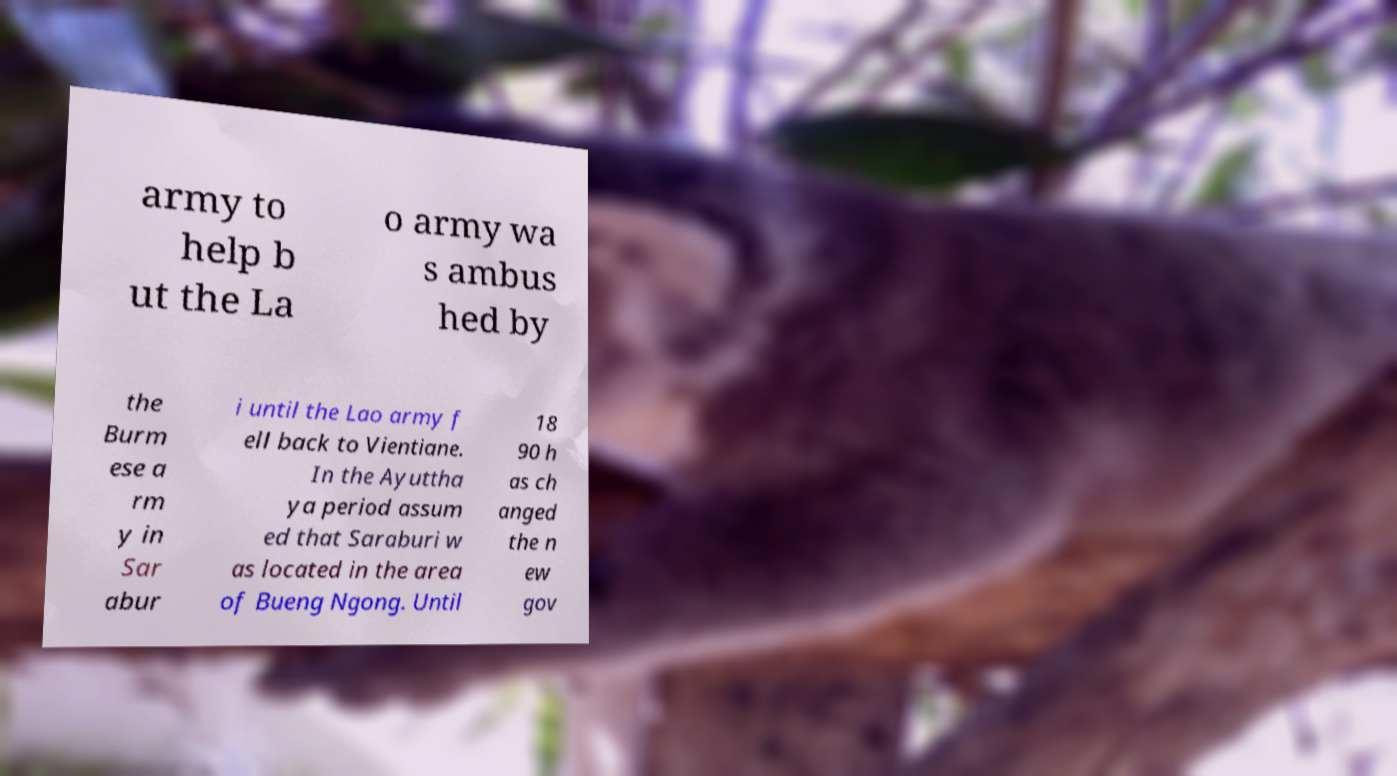Could you assist in decoding the text presented in this image and type it out clearly? army to help b ut the La o army wa s ambus hed by the Burm ese a rm y in Sar abur i until the Lao army f ell back to Vientiane. In the Ayuttha ya period assum ed that Saraburi w as located in the area of Bueng Ngong. Until 18 90 h as ch anged the n ew gov 